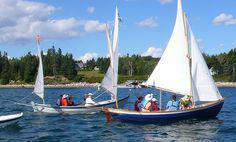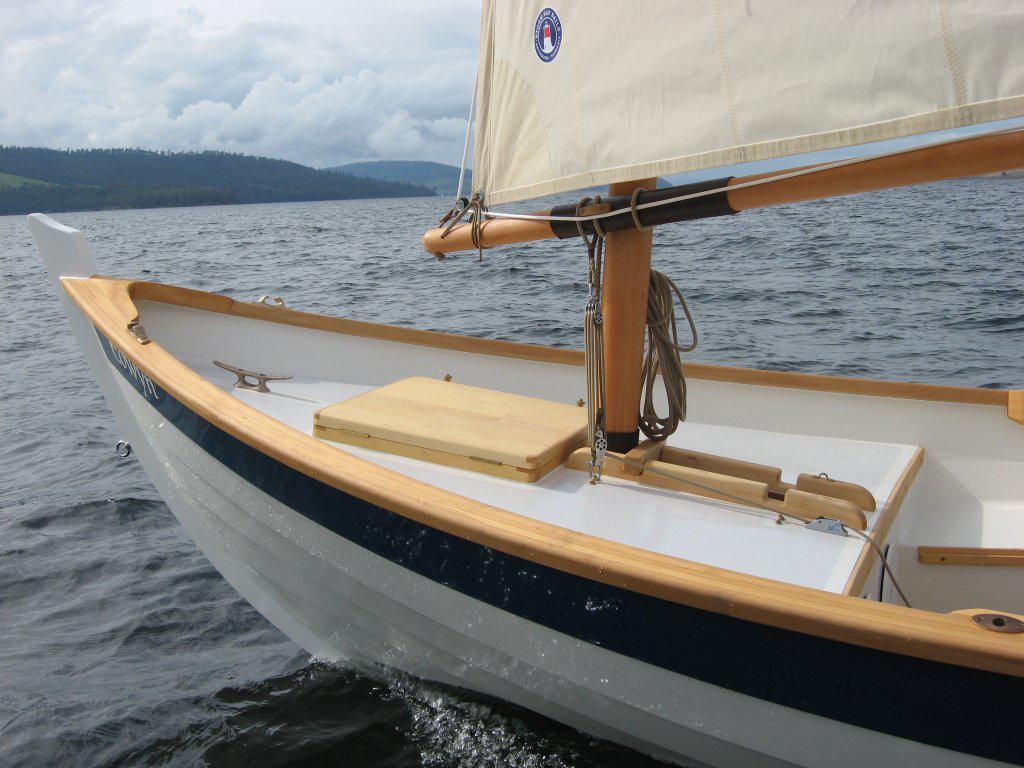The first image is the image on the left, the second image is the image on the right. Examine the images to the left and right. Is the description "People are in two boats in the water in the image on the left." accurate? Answer yes or no. Yes. 